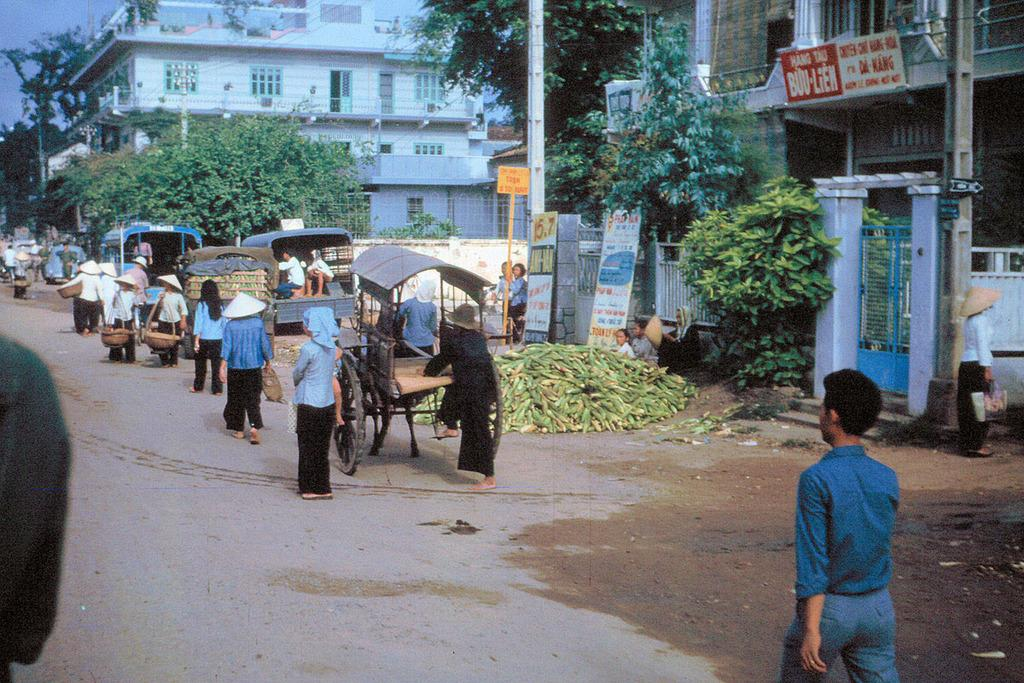What are the people in the image doing? There are persons walking on the road in the image. What can be seen in the background of the image? There are buildings and trees visible in the image. What type of food is present in the image? There are corns in the image. What kind of signs or messages are displayed in the image? There are boards with text in the image. Are there any masks or headgear visible on the persons walking in the image? There is no mention of masks or headgear in the provided facts, so we cannot determine if they are present in the image. Can you tell me how many turkeys are walking alongside the persons in the image? There is no mention of turkeys in the provided facts, so we cannot determine if they are present in the image. 